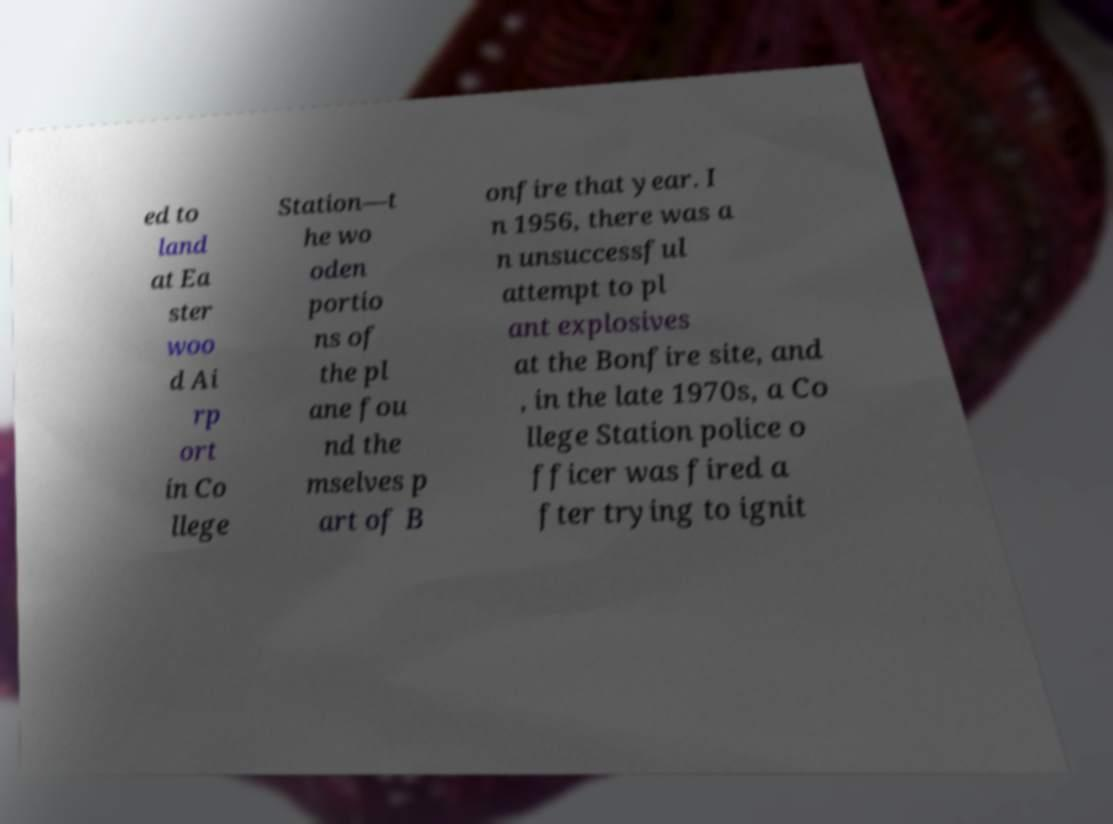There's text embedded in this image that I need extracted. Can you transcribe it verbatim? ed to land at Ea ster woo d Ai rp ort in Co llege Station—t he wo oden portio ns of the pl ane fou nd the mselves p art of B onfire that year. I n 1956, there was a n unsuccessful attempt to pl ant explosives at the Bonfire site, and , in the late 1970s, a Co llege Station police o fficer was fired a fter trying to ignit 